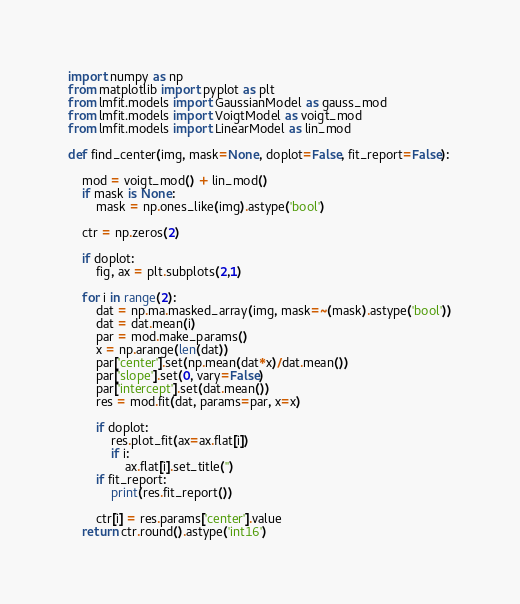<code> <loc_0><loc_0><loc_500><loc_500><_Python_>import numpy as np
from matplotlib import pyplot as plt
from lmfit.models import GaussianModel as gauss_mod
from lmfit.models import VoigtModel as voigt_mod
from lmfit.models import LinearModel as lin_mod

def find_center(img, mask=None, doplot=False, fit_report=False):
    
    mod = voigt_mod() + lin_mod()
    if mask is None:
        mask = np.ones_like(img).astype('bool')
        
    ctr = np.zeros(2)
    
    if doplot:
        fig, ax = plt.subplots(2,1)
    
    for i in range(2):
        dat = np.ma.masked_array(img, mask=~(mask).astype('bool'))
        dat = dat.mean(i)
        par = mod.make_params()
        x = np.arange(len(dat))
        par['center'].set(np.mean(dat*x)/dat.mean())
        par['slope'].set(0, vary=False)
        par['intercept'].set(dat.mean())
        res = mod.fit(dat, params=par, x=x)
        
        if doplot:
            res.plot_fit(ax=ax.flat[i])
            if i:
                ax.flat[i].set_title('')
        if fit_report:
            print(res.fit_report())
            
        ctr[i] = res.params['center'].value
    return ctr.round().astype('int16')
</code> 